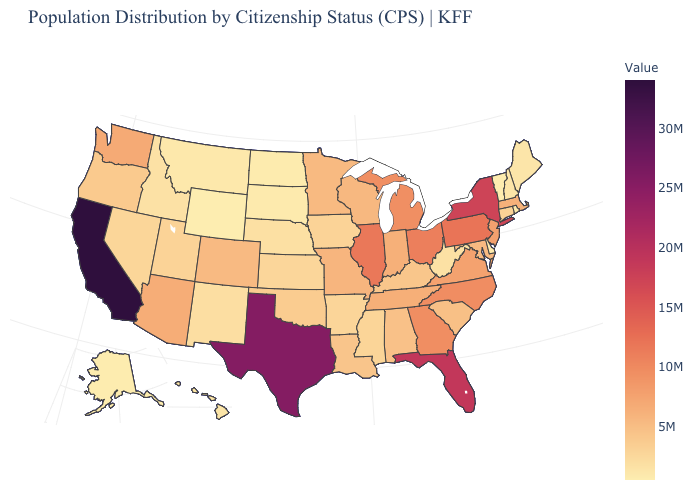Which states have the highest value in the USA?
Quick response, please. California. Does Oklahoma have the lowest value in the South?
Be succinct. No. Which states hav the highest value in the West?
Be succinct. California. Which states hav the highest value in the West?
Short answer required. California. Does Maine have the highest value in the Northeast?
Keep it brief. No. 